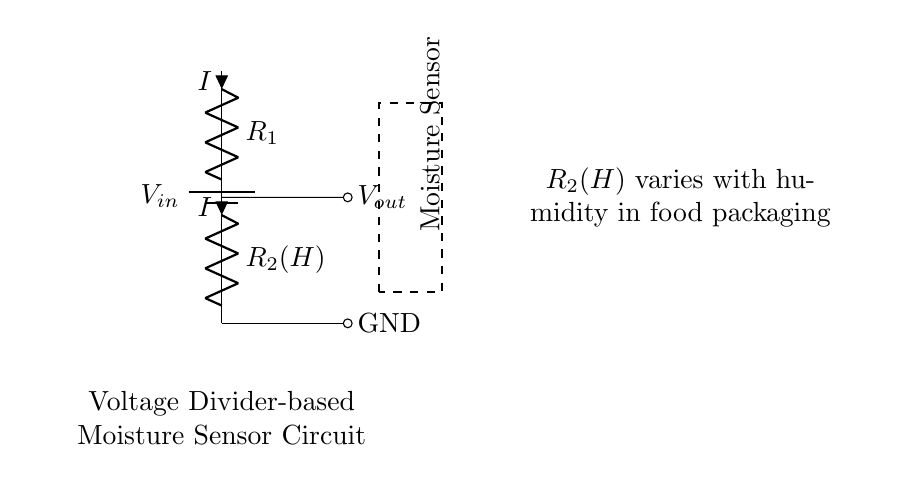What type of circuit is depicted? This circuit is a voltage divider, which typically consists of two resistors arranged in series and allows for the division of input voltage based on the resistor values.
Answer: voltage divider What does the resistor R2 represent in this circuit? R2 represents a variable resistor, specifically a moisture-sensitive resistor, which changes its resistance value based on the humidity levels in food packaging.
Answer: moisture sensor What is the purpose of the output voltage, Vout? The output voltage, Vout, provides the voltage level that indicates the moisture content detected by the sensor, which is critical for assessing the humidity in food packaging.
Answer: indicate moisture content Which component in the circuit varies with humidity? R2 varies with humidity, as it is specifically designed to change its resistance in response to the moisture levels present around it.
Answer: R2 What does the current I in the circuit signify? The current I represents the flow of electric charge through the circuit, determined by the voltage applied and the resistances in the voltage divider according to Ohm's law.
Answer: current flow How does increasing humidity affect Vout? Increasing humidity reduces the resistance of R2, leading to a higher Vout due to the voltage division principle in the circuit, which results in a lower effective load resistance.
Answer: Vout increases What happens to the output voltage if R1 is increased? If R1 is increased, the overall resistance of the voltage divider increases, which will decrease the output voltage, as Vout depends on the ratio of R2 to R1 and the input voltage.
Answer: Vout decreases 